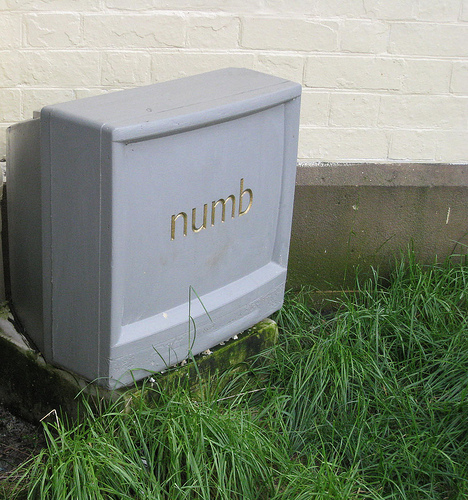<image>
Is there a television on the grass? Yes. Looking at the image, I can see the television is positioned on top of the grass, with the grass providing support. 